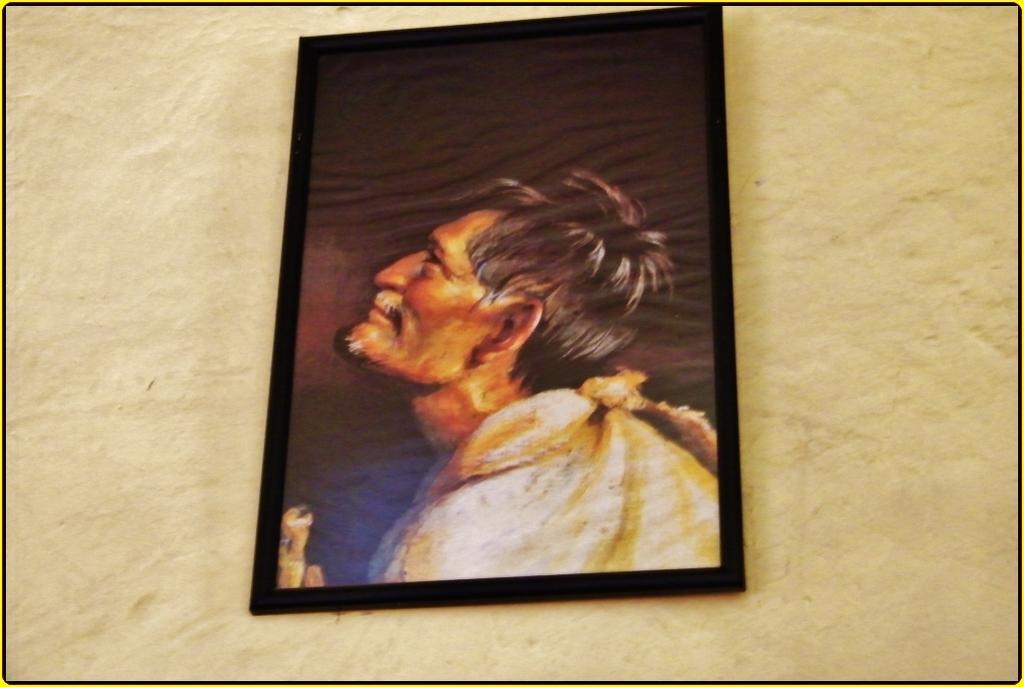In one or two sentences, can you explain what this image depicts? In the center of the picture there is a frame attached to the wall. 